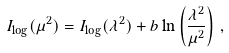<formula> <loc_0><loc_0><loc_500><loc_500>I _ { \log } ( \mu ^ { 2 } ) = I _ { \log } ( \lambda ^ { 2 } ) + b \ln \left ( \frac { \lambda ^ { 2 } } { \mu ^ { 2 } } \right ) \, ,</formula> 